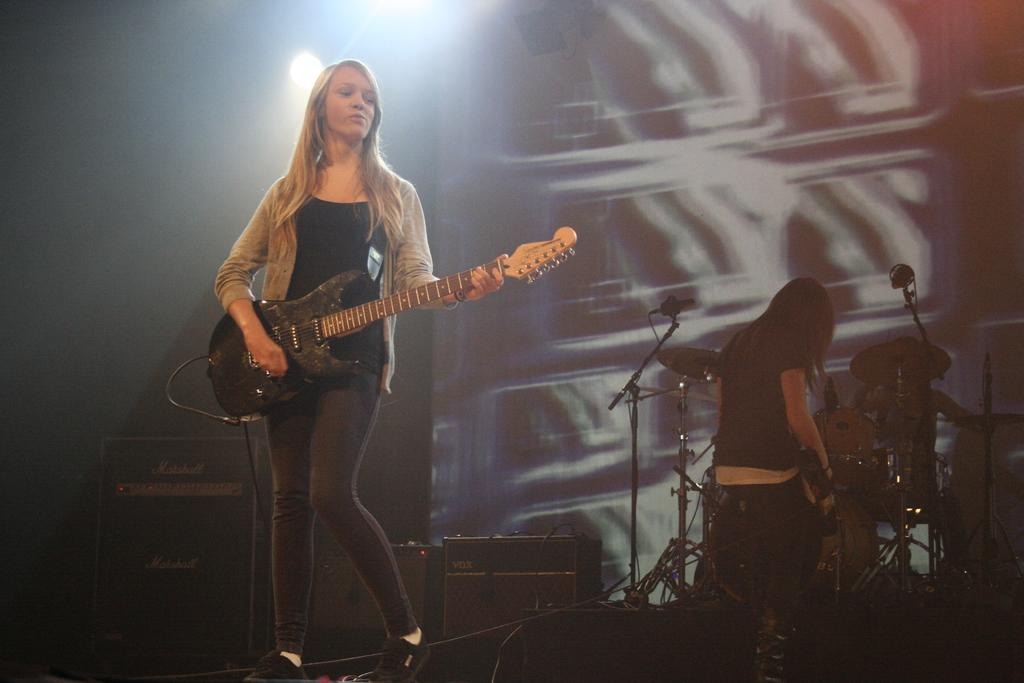What is the woman in the image doing? The woman standing in the image is playing a guitar. Can you describe the other woman in the image? The other woman is seated and holding a guitar. What other musical instruments can be seen in the image? There are drums visible in the image. What equipment might be used for amplifying sound in the image? There are microphones present in the image. What is the low theory of the music being played in the image? There is no information provided about the music being played or any specific theory related to it, so this question cannot be answered definitively. 